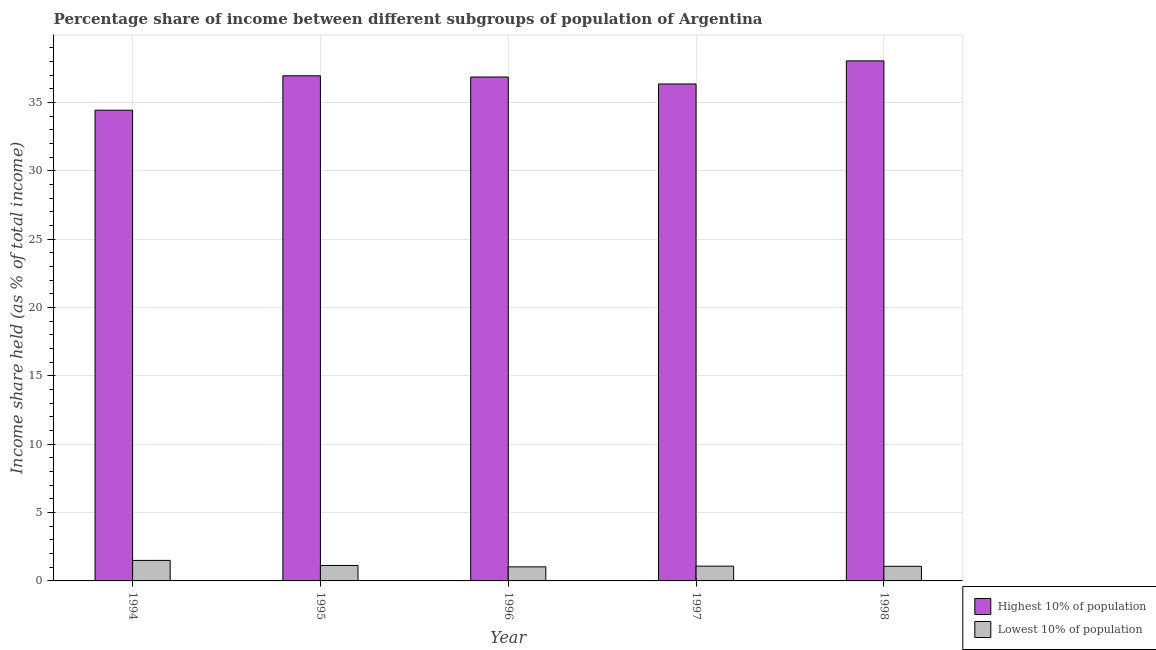How many different coloured bars are there?
Make the answer very short. 2. How many bars are there on the 3rd tick from the left?
Give a very brief answer. 2. In how many cases, is the number of bars for a given year not equal to the number of legend labels?
Your response must be concise. 0. What is the income share held by lowest 10% of the population in 1996?
Keep it short and to the point. 1.03. Across all years, what is the maximum income share held by highest 10% of the population?
Offer a very short reply. 38.05. What is the total income share held by highest 10% of the population in the graph?
Provide a succinct answer. 182.68. What is the difference between the income share held by highest 10% of the population in 1996 and that in 1997?
Make the answer very short. 0.51. What is the difference between the income share held by lowest 10% of the population in 1997 and the income share held by highest 10% of the population in 1994?
Give a very brief answer. -0.42. What is the average income share held by highest 10% of the population per year?
Ensure brevity in your answer.  36.54. What is the ratio of the income share held by lowest 10% of the population in 1996 to that in 1998?
Give a very brief answer. 0.96. Is the difference between the income share held by highest 10% of the population in 1996 and 1997 greater than the difference between the income share held by lowest 10% of the population in 1996 and 1997?
Provide a short and direct response. No. What is the difference between the highest and the second highest income share held by lowest 10% of the population?
Your answer should be compact. 0.37. What is the difference between the highest and the lowest income share held by highest 10% of the population?
Make the answer very short. 3.61. What does the 1st bar from the left in 1998 represents?
Your answer should be very brief. Highest 10% of population. What does the 1st bar from the right in 1996 represents?
Your answer should be compact. Lowest 10% of population. Are all the bars in the graph horizontal?
Offer a terse response. No. How many years are there in the graph?
Your answer should be very brief. 5. What is the difference between two consecutive major ticks on the Y-axis?
Offer a terse response. 5. How are the legend labels stacked?
Provide a succinct answer. Vertical. What is the title of the graph?
Keep it short and to the point. Percentage share of income between different subgroups of population of Argentina. Does "Arms exports" appear as one of the legend labels in the graph?
Your response must be concise. No. What is the label or title of the X-axis?
Offer a very short reply. Year. What is the label or title of the Y-axis?
Keep it short and to the point. Income share held (as % of total income). What is the Income share held (as % of total income) in Highest 10% of population in 1994?
Ensure brevity in your answer.  34.44. What is the Income share held (as % of total income) of Lowest 10% of population in 1994?
Your answer should be very brief. 1.5. What is the Income share held (as % of total income) in Highest 10% of population in 1995?
Ensure brevity in your answer.  36.96. What is the Income share held (as % of total income) in Lowest 10% of population in 1995?
Give a very brief answer. 1.13. What is the Income share held (as % of total income) of Highest 10% of population in 1996?
Your answer should be very brief. 36.87. What is the Income share held (as % of total income) in Lowest 10% of population in 1996?
Provide a succinct answer. 1.03. What is the Income share held (as % of total income) of Highest 10% of population in 1997?
Your answer should be compact. 36.36. What is the Income share held (as % of total income) of Highest 10% of population in 1998?
Your answer should be compact. 38.05. What is the Income share held (as % of total income) in Lowest 10% of population in 1998?
Keep it short and to the point. 1.07. Across all years, what is the maximum Income share held (as % of total income) in Highest 10% of population?
Provide a short and direct response. 38.05. Across all years, what is the minimum Income share held (as % of total income) of Highest 10% of population?
Your answer should be very brief. 34.44. What is the total Income share held (as % of total income) of Highest 10% of population in the graph?
Your response must be concise. 182.68. What is the total Income share held (as % of total income) of Lowest 10% of population in the graph?
Provide a succinct answer. 5.81. What is the difference between the Income share held (as % of total income) of Highest 10% of population in 1994 and that in 1995?
Offer a very short reply. -2.52. What is the difference between the Income share held (as % of total income) in Lowest 10% of population in 1994 and that in 1995?
Ensure brevity in your answer.  0.37. What is the difference between the Income share held (as % of total income) of Highest 10% of population in 1994 and that in 1996?
Offer a terse response. -2.43. What is the difference between the Income share held (as % of total income) of Lowest 10% of population in 1994 and that in 1996?
Your response must be concise. 0.47. What is the difference between the Income share held (as % of total income) in Highest 10% of population in 1994 and that in 1997?
Your response must be concise. -1.92. What is the difference between the Income share held (as % of total income) in Lowest 10% of population in 1994 and that in 1997?
Provide a succinct answer. 0.42. What is the difference between the Income share held (as % of total income) of Highest 10% of population in 1994 and that in 1998?
Your answer should be compact. -3.61. What is the difference between the Income share held (as % of total income) of Lowest 10% of population in 1994 and that in 1998?
Provide a succinct answer. 0.43. What is the difference between the Income share held (as % of total income) of Highest 10% of population in 1995 and that in 1996?
Provide a short and direct response. 0.09. What is the difference between the Income share held (as % of total income) in Lowest 10% of population in 1995 and that in 1997?
Your answer should be compact. 0.05. What is the difference between the Income share held (as % of total income) in Highest 10% of population in 1995 and that in 1998?
Make the answer very short. -1.09. What is the difference between the Income share held (as % of total income) in Highest 10% of population in 1996 and that in 1997?
Provide a succinct answer. 0.51. What is the difference between the Income share held (as % of total income) in Highest 10% of population in 1996 and that in 1998?
Keep it short and to the point. -1.18. What is the difference between the Income share held (as % of total income) of Lowest 10% of population in 1996 and that in 1998?
Provide a short and direct response. -0.04. What is the difference between the Income share held (as % of total income) in Highest 10% of population in 1997 and that in 1998?
Offer a very short reply. -1.69. What is the difference between the Income share held (as % of total income) of Highest 10% of population in 1994 and the Income share held (as % of total income) of Lowest 10% of population in 1995?
Ensure brevity in your answer.  33.31. What is the difference between the Income share held (as % of total income) in Highest 10% of population in 1994 and the Income share held (as % of total income) in Lowest 10% of population in 1996?
Give a very brief answer. 33.41. What is the difference between the Income share held (as % of total income) in Highest 10% of population in 1994 and the Income share held (as % of total income) in Lowest 10% of population in 1997?
Provide a succinct answer. 33.36. What is the difference between the Income share held (as % of total income) in Highest 10% of population in 1994 and the Income share held (as % of total income) in Lowest 10% of population in 1998?
Provide a succinct answer. 33.37. What is the difference between the Income share held (as % of total income) in Highest 10% of population in 1995 and the Income share held (as % of total income) in Lowest 10% of population in 1996?
Make the answer very short. 35.93. What is the difference between the Income share held (as % of total income) in Highest 10% of population in 1995 and the Income share held (as % of total income) in Lowest 10% of population in 1997?
Ensure brevity in your answer.  35.88. What is the difference between the Income share held (as % of total income) of Highest 10% of population in 1995 and the Income share held (as % of total income) of Lowest 10% of population in 1998?
Provide a short and direct response. 35.89. What is the difference between the Income share held (as % of total income) of Highest 10% of population in 1996 and the Income share held (as % of total income) of Lowest 10% of population in 1997?
Keep it short and to the point. 35.79. What is the difference between the Income share held (as % of total income) of Highest 10% of population in 1996 and the Income share held (as % of total income) of Lowest 10% of population in 1998?
Provide a succinct answer. 35.8. What is the difference between the Income share held (as % of total income) in Highest 10% of population in 1997 and the Income share held (as % of total income) in Lowest 10% of population in 1998?
Provide a short and direct response. 35.29. What is the average Income share held (as % of total income) of Highest 10% of population per year?
Your answer should be compact. 36.54. What is the average Income share held (as % of total income) in Lowest 10% of population per year?
Your answer should be compact. 1.16. In the year 1994, what is the difference between the Income share held (as % of total income) of Highest 10% of population and Income share held (as % of total income) of Lowest 10% of population?
Offer a terse response. 32.94. In the year 1995, what is the difference between the Income share held (as % of total income) of Highest 10% of population and Income share held (as % of total income) of Lowest 10% of population?
Provide a short and direct response. 35.83. In the year 1996, what is the difference between the Income share held (as % of total income) in Highest 10% of population and Income share held (as % of total income) in Lowest 10% of population?
Keep it short and to the point. 35.84. In the year 1997, what is the difference between the Income share held (as % of total income) in Highest 10% of population and Income share held (as % of total income) in Lowest 10% of population?
Offer a terse response. 35.28. In the year 1998, what is the difference between the Income share held (as % of total income) in Highest 10% of population and Income share held (as % of total income) in Lowest 10% of population?
Provide a short and direct response. 36.98. What is the ratio of the Income share held (as % of total income) of Highest 10% of population in 1994 to that in 1995?
Provide a short and direct response. 0.93. What is the ratio of the Income share held (as % of total income) in Lowest 10% of population in 1994 to that in 1995?
Your answer should be compact. 1.33. What is the ratio of the Income share held (as % of total income) of Highest 10% of population in 1994 to that in 1996?
Provide a short and direct response. 0.93. What is the ratio of the Income share held (as % of total income) in Lowest 10% of population in 1994 to that in 1996?
Your response must be concise. 1.46. What is the ratio of the Income share held (as % of total income) in Highest 10% of population in 1994 to that in 1997?
Keep it short and to the point. 0.95. What is the ratio of the Income share held (as % of total income) of Lowest 10% of population in 1994 to that in 1997?
Ensure brevity in your answer.  1.39. What is the ratio of the Income share held (as % of total income) of Highest 10% of population in 1994 to that in 1998?
Give a very brief answer. 0.91. What is the ratio of the Income share held (as % of total income) of Lowest 10% of population in 1994 to that in 1998?
Give a very brief answer. 1.4. What is the ratio of the Income share held (as % of total income) in Highest 10% of population in 1995 to that in 1996?
Give a very brief answer. 1. What is the ratio of the Income share held (as % of total income) in Lowest 10% of population in 1995 to that in 1996?
Ensure brevity in your answer.  1.1. What is the ratio of the Income share held (as % of total income) of Highest 10% of population in 1995 to that in 1997?
Provide a short and direct response. 1.02. What is the ratio of the Income share held (as % of total income) in Lowest 10% of population in 1995 to that in 1997?
Offer a terse response. 1.05. What is the ratio of the Income share held (as % of total income) of Highest 10% of population in 1995 to that in 1998?
Your response must be concise. 0.97. What is the ratio of the Income share held (as % of total income) of Lowest 10% of population in 1995 to that in 1998?
Your answer should be compact. 1.06. What is the ratio of the Income share held (as % of total income) of Highest 10% of population in 1996 to that in 1997?
Keep it short and to the point. 1.01. What is the ratio of the Income share held (as % of total income) of Lowest 10% of population in 1996 to that in 1997?
Keep it short and to the point. 0.95. What is the ratio of the Income share held (as % of total income) of Lowest 10% of population in 1996 to that in 1998?
Offer a terse response. 0.96. What is the ratio of the Income share held (as % of total income) in Highest 10% of population in 1997 to that in 1998?
Ensure brevity in your answer.  0.96. What is the ratio of the Income share held (as % of total income) of Lowest 10% of population in 1997 to that in 1998?
Your response must be concise. 1.01. What is the difference between the highest and the second highest Income share held (as % of total income) of Highest 10% of population?
Provide a succinct answer. 1.09. What is the difference between the highest and the second highest Income share held (as % of total income) in Lowest 10% of population?
Your answer should be very brief. 0.37. What is the difference between the highest and the lowest Income share held (as % of total income) in Highest 10% of population?
Your answer should be compact. 3.61. What is the difference between the highest and the lowest Income share held (as % of total income) of Lowest 10% of population?
Ensure brevity in your answer.  0.47. 